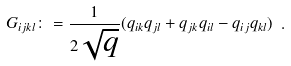<formula> <loc_0><loc_0><loc_500><loc_500>G _ { i j k l } \colon = \frac { 1 } { 2 \sqrt { q } } ( q _ { i k } q _ { j l } + q _ { j k } q _ { i l } - q _ { i j } q _ { k l } ) \ .</formula> 